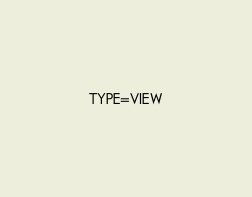Convert code to text. <code><loc_0><loc_0><loc_500><loc_500><_VisualBasic_>TYPE=VIEW</code> 